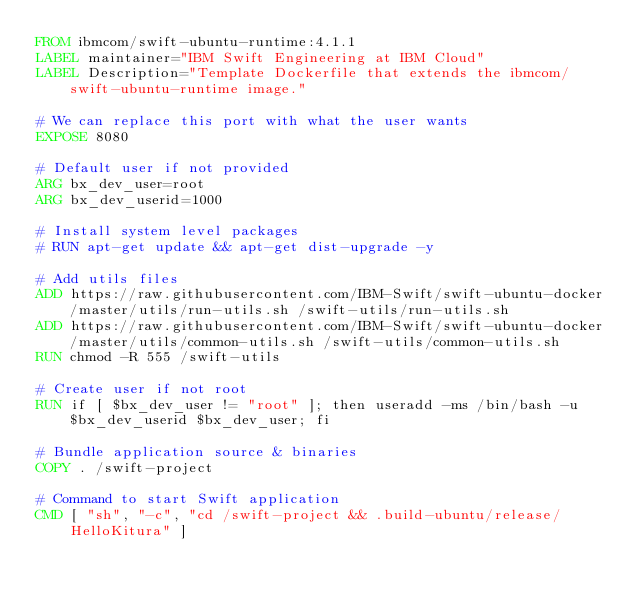<code> <loc_0><loc_0><loc_500><loc_500><_Dockerfile_>FROM ibmcom/swift-ubuntu-runtime:4.1.1
LABEL maintainer="IBM Swift Engineering at IBM Cloud"
LABEL Description="Template Dockerfile that extends the ibmcom/swift-ubuntu-runtime image."

# We can replace this port with what the user wants
EXPOSE 8080

# Default user if not provided
ARG bx_dev_user=root
ARG bx_dev_userid=1000

# Install system level packages
# RUN apt-get update && apt-get dist-upgrade -y

# Add utils files
ADD https://raw.githubusercontent.com/IBM-Swift/swift-ubuntu-docker/master/utils/run-utils.sh /swift-utils/run-utils.sh
ADD https://raw.githubusercontent.com/IBM-Swift/swift-ubuntu-docker/master/utils/common-utils.sh /swift-utils/common-utils.sh
RUN chmod -R 555 /swift-utils

# Create user if not root
RUN if [ $bx_dev_user != "root" ]; then useradd -ms /bin/bash -u $bx_dev_userid $bx_dev_user; fi

# Bundle application source & binaries
COPY . /swift-project

# Command to start Swift application
CMD [ "sh", "-c", "cd /swift-project && .build-ubuntu/release/HelloKitura" ]
</code> 